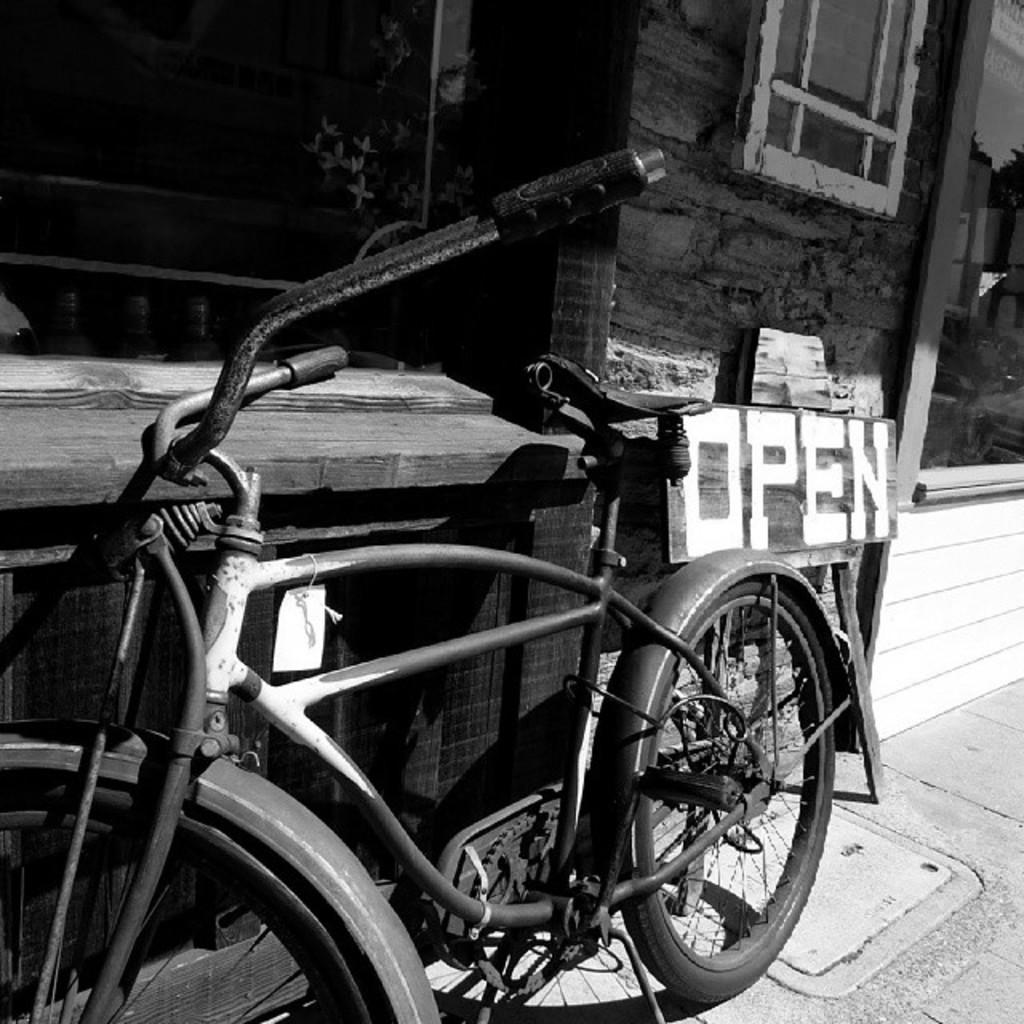What is inside the wooden object in the image? There is a bicycle inside a wooden object in the image. What can be found on the wooden board? There is text on the wooden board. What type of vegetation is present in the image? There are plants in the image. What architectural feature is visible in the image? There is a window in the image. What part of a house can be seen in the image? There is a glass door of a house in the image. What type of harmony can be heard in the image? There is no audible sound in the image, so it is not possible to determine if there is any harmony present. 